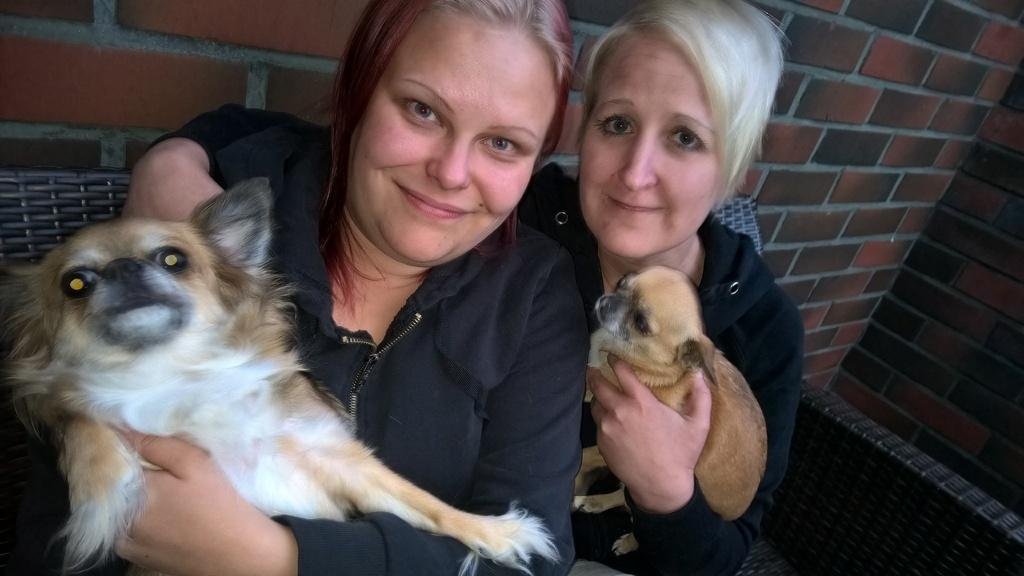How many women are present in the image? There are two women in the image. What are the women holding in the image? Both women are holding dogs. What expression do the women have in the image? The women are smiling. What type of clothing are the women wearing in the image? The women are wearing jackets. What type of metal can be seen on the women's legs in the image? There is no metal visible on the women's legs in the image. 